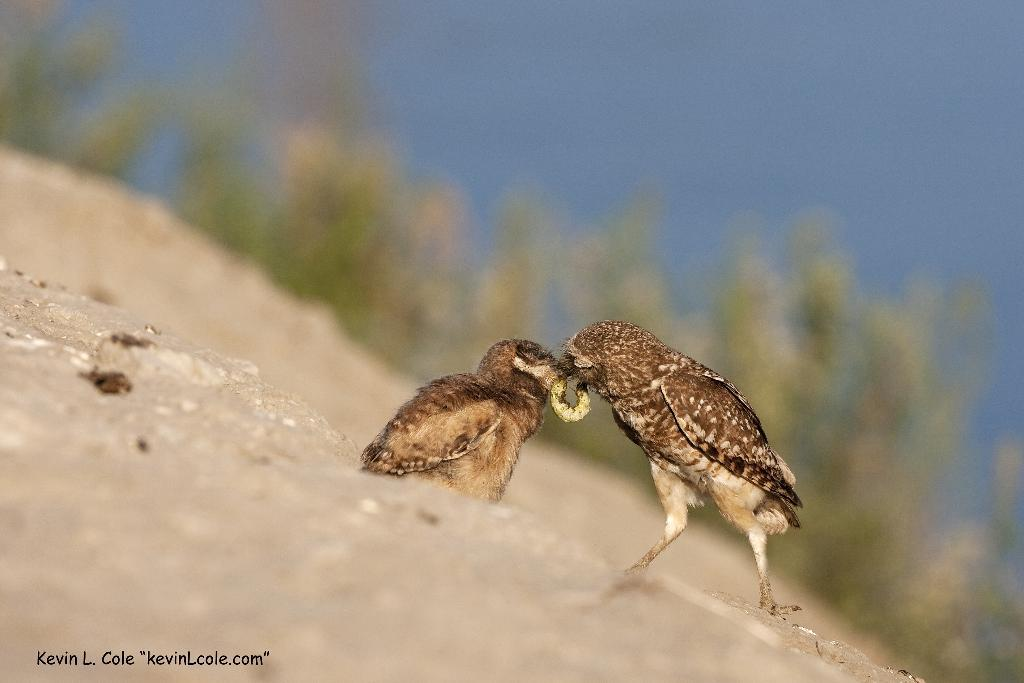What is the main subject of the image? The main subject of the image is birds. What are the birds doing in the image? The birds are eating in the image. Are there any other living creatures present in the image? Yes, there is an insect in the image. What can be seen in the background of the image? There are trees in the background of the image. What material is visible at the bottom of the image? There is wood at the bottom of the image. Is there any text visible in the image? Yes, there is some text visible in the image. What type of muscle can be seen flexing in the image? There is no muscle visible in the image; it features birds eating and an insect. What game is being played by the birds in the image? There is no game being played in the image; the birds are simply eating. 